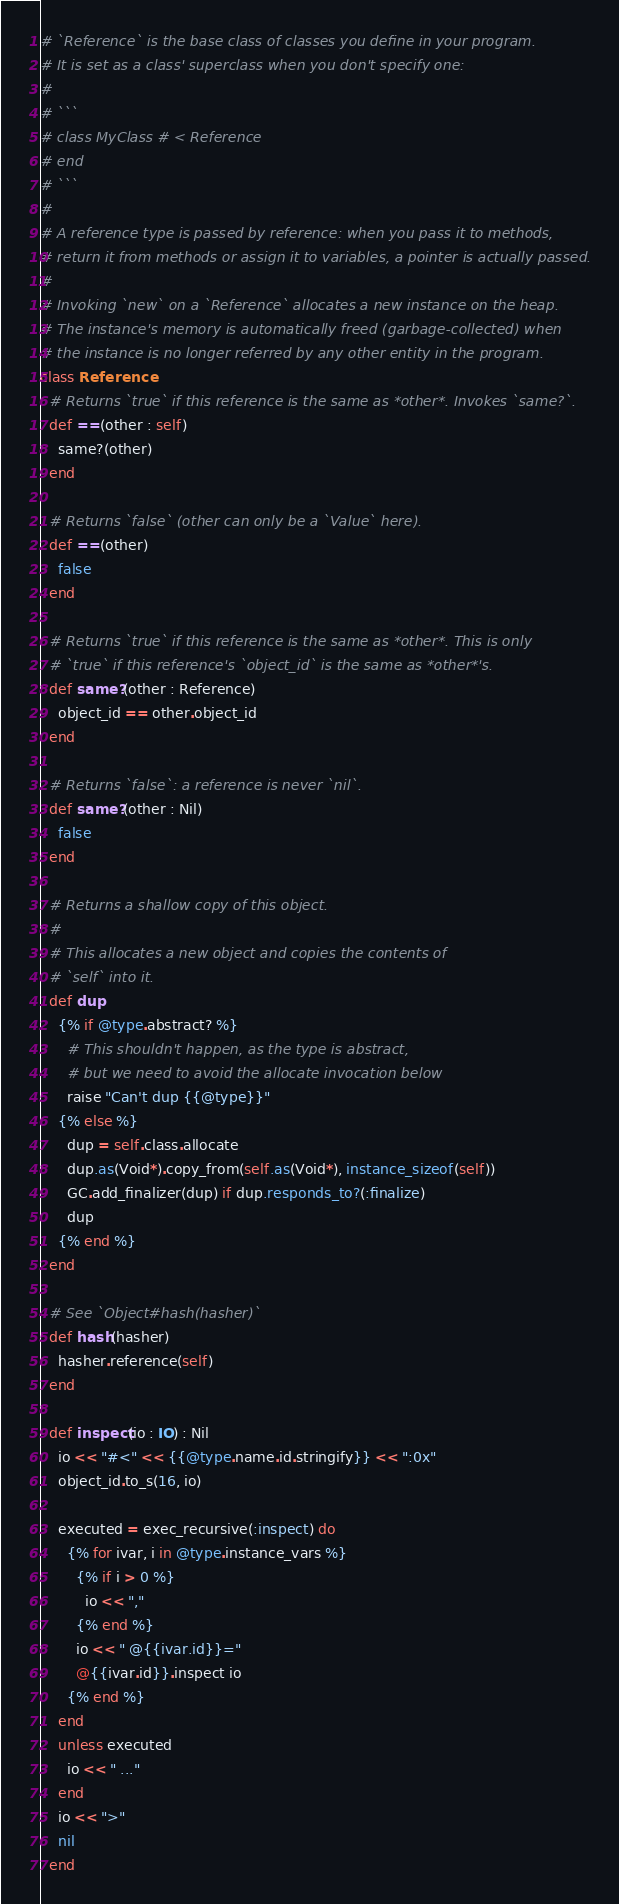Convert code to text. <code><loc_0><loc_0><loc_500><loc_500><_Crystal_># `Reference` is the base class of classes you define in your program.
# It is set as a class' superclass when you don't specify one:
#
# ```
# class MyClass # < Reference
# end
# ```
#
# A reference type is passed by reference: when you pass it to methods,
# return it from methods or assign it to variables, a pointer is actually passed.
#
# Invoking `new` on a `Reference` allocates a new instance on the heap.
# The instance's memory is automatically freed (garbage-collected) when
# the instance is no longer referred by any other entity in the program.
class Reference
  # Returns `true` if this reference is the same as *other*. Invokes `same?`.
  def ==(other : self)
    same?(other)
  end

  # Returns `false` (other can only be a `Value` here).
  def ==(other)
    false
  end

  # Returns `true` if this reference is the same as *other*. This is only
  # `true` if this reference's `object_id` is the same as *other*'s.
  def same?(other : Reference)
    object_id == other.object_id
  end

  # Returns `false`: a reference is never `nil`.
  def same?(other : Nil)
    false
  end

  # Returns a shallow copy of this object.
  #
  # This allocates a new object and copies the contents of
  # `self` into it.
  def dup
    {% if @type.abstract? %}
      # This shouldn't happen, as the type is abstract,
      # but we need to avoid the allocate invocation below
      raise "Can't dup {{@type}}"
    {% else %}
      dup = self.class.allocate
      dup.as(Void*).copy_from(self.as(Void*), instance_sizeof(self))
      GC.add_finalizer(dup) if dup.responds_to?(:finalize)
      dup
    {% end %}
  end

  # See `Object#hash(hasher)`
  def hash(hasher)
    hasher.reference(self)
  end

  def inspect(io : IO) : Nil
    io << "#<" << {{@type.name.id.stringify}} << ":0x"
    object_id.to_s(16, io)

    executed = exec_recursive(:inspect) do
      {% for ivar, i in @type.instance_vars %}
        {% if i > 0 %}
          io << ","
        {% end %}
        io << " @{{ivar.id}}="
        @{{ivar.id}}.inspect io
      {% end %}
    end
    unless executed
      io << " ..."
    end
    io << ">"
    nil
  end
</code> 